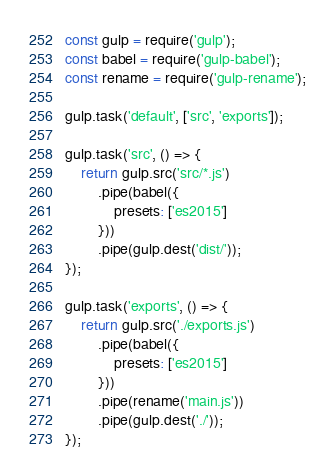<code> <loc_0><loc_0><loc_500><loc_500><_JavaScript_>const gulp = require('gulp');
const babel = require('gulp-babel');
const rename = require('gulp-rename');

gulp.task('default', ['src', 'exports']);

gulp.task('src', () => {
    return gulp.src('src/*.js')
        .pipe(babel({
            presets: ['es2015']
        }))
        .pipe(gulp.dest('dist/'));
});

gulp.task('exports', () => {
    return gulp.src('./exports.js')
        .pipe(babel({
            presets: ['es2015']
        }))
        .pipe(rename('main.js'))
        .pipe(gulp.dest('./'));
});

</code> 